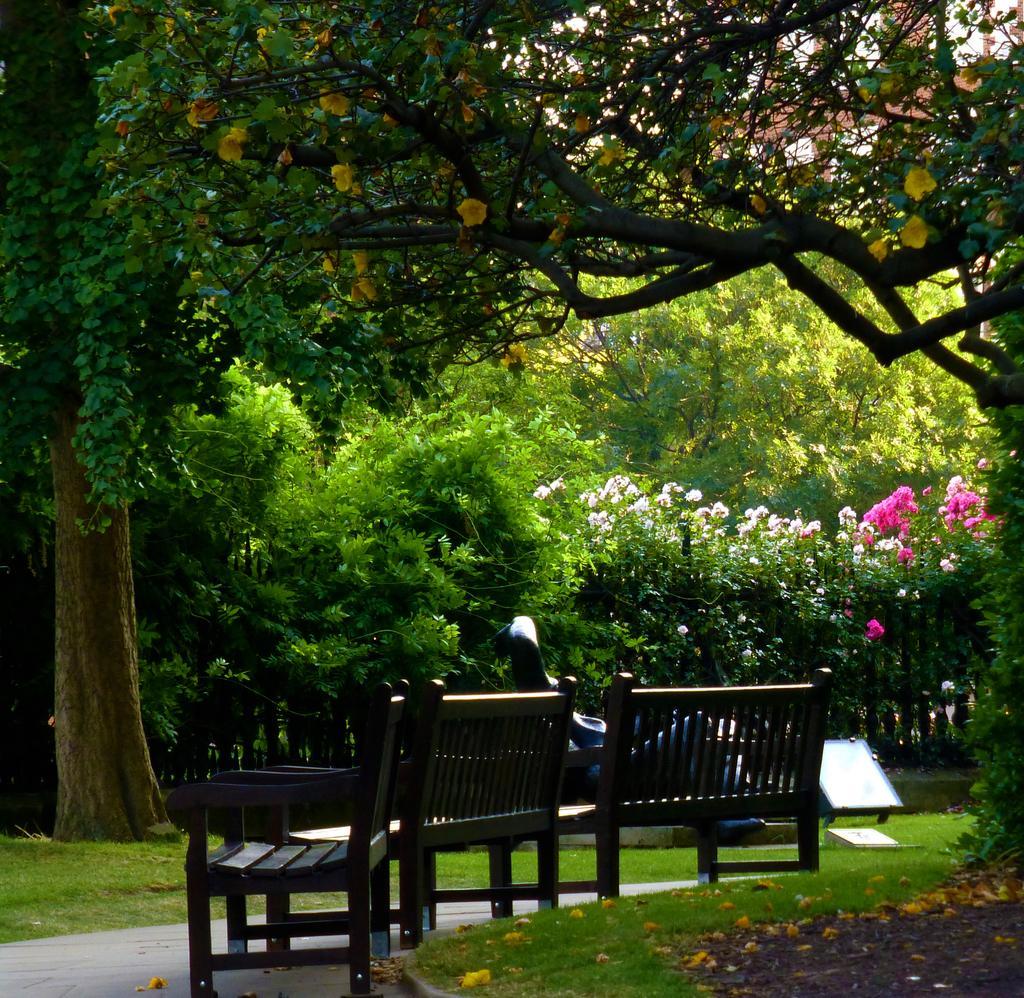Could you give a brief overview of what you see in this image? There is a garden and it is covered with beautiful trees and plants,in between the garden there are two benches and a wooden chair. 